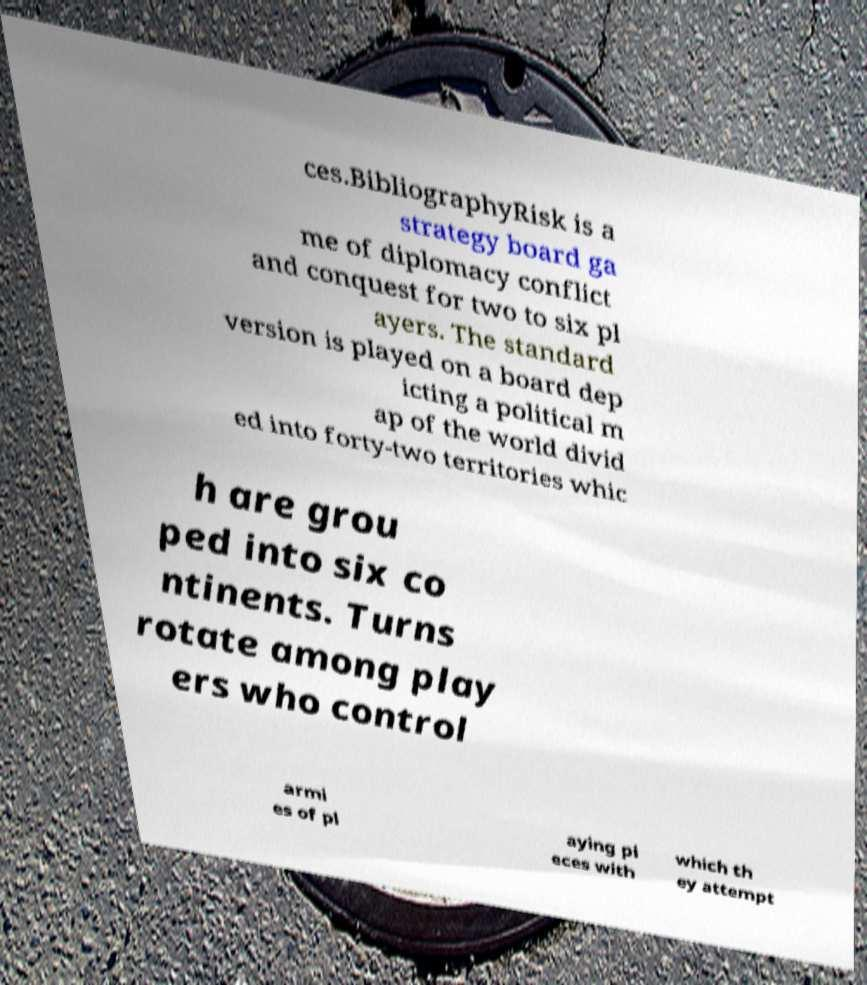Please identify and transcribe the text found in this image. ces.BibliographyRisk is a strategy board ga me of diplomacy conflict and conquest for two to six pl ayers. The standard version is played on a board dep icting a political m ap of the world divid ed into forty-two territories whic h are grou ped into six co ntinents. Turns rotate among play ers who control armi es of pl aying pi eces with which th ey attempt 